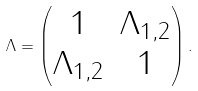<formula> <loc_0><loc_0><loc_500><loc_500>\Lambda = \begin{pmatrix} 1 & \Lambda _ { 1 , 2 } \\ \Lambda _ { 1 , 2 } & 1 \end{pmatrix} .</formula> 